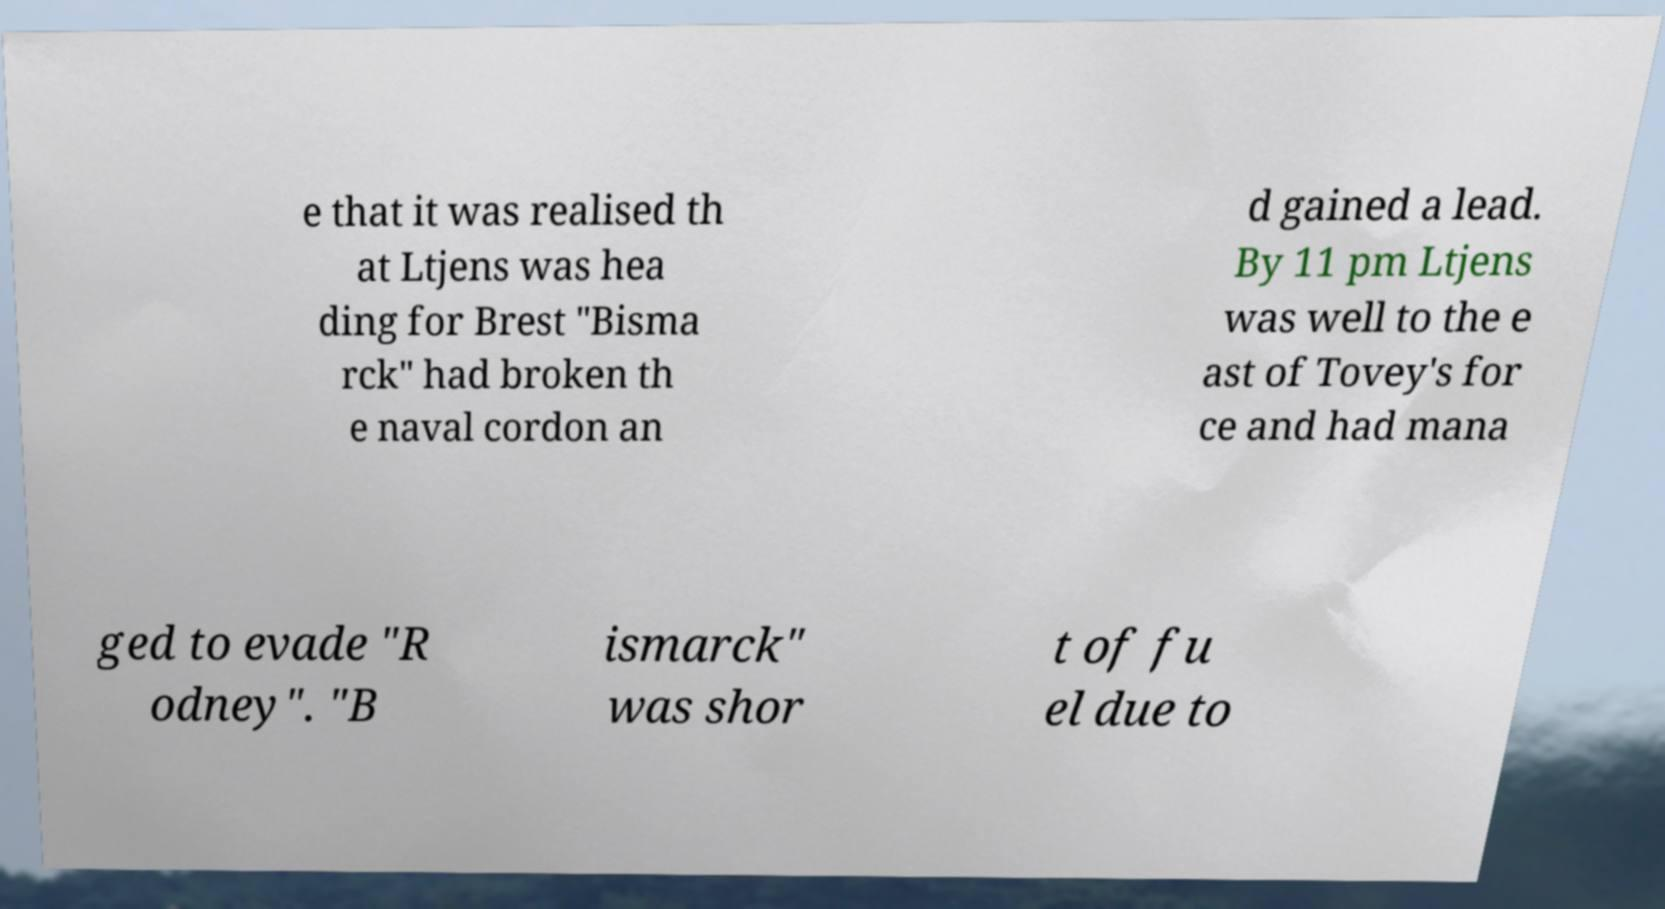Could you assist in decoding the text presented in this image and type it out clearly? e that it was realised th at Ltjens was hea ding for Brest "Bisma rck" had broken th e naval cordon an d gained a lead. By 11 pm Ltjens was well to the e ast of Tovey's for ce and had mana ged to evade "R odney". "B ismarck" was shor t of fu el due to 